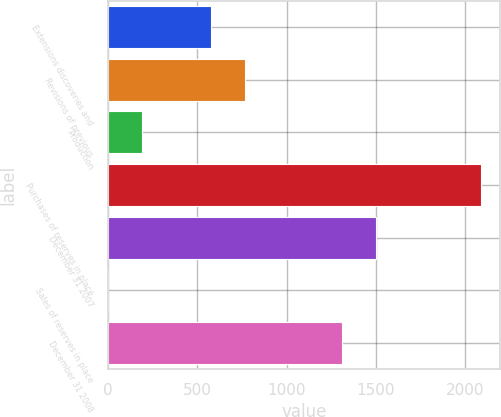Convert chart to OTSL. <chart><loc_0><loc_0><loc_500><loc_500><bar_chart><fcel>Extensions discoveries and<fcel>Revisions of previous<fcel>Production<fcel>Purchases of reserves in place<fcel>December 31 2007<fcel>Sales of reserves in place<fcel>December 31 2008<nl><fcel>576.4<fcel>768.2<fcel>192.8<fcel>2087.8<fcel>1501.8<fcel>1<fcel>1310<nl></chart> 